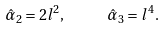<formula> <loc_0><loc_0><loc_500><loc_500>\hat { \alpha } _ { 2 } = 2 l ^ { 2 } , \text { \quad \ } \hat { \alpha } _ { 3 } = l ^ { 4 } .</formula> 